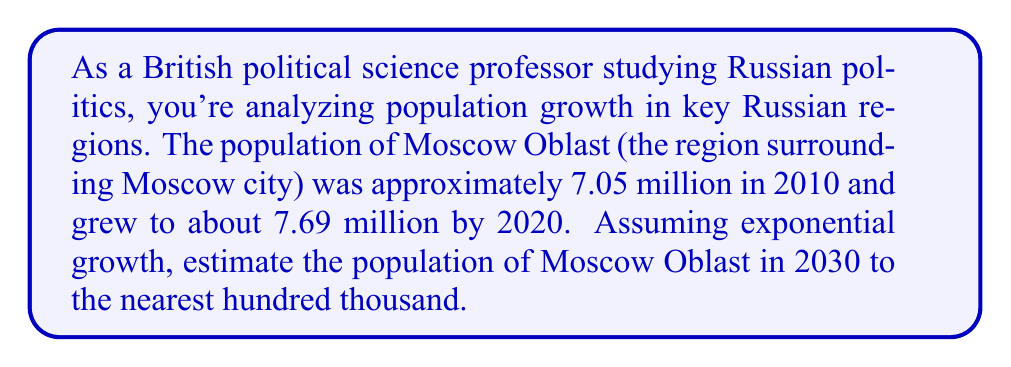Provide a solution to this math problem. To solve this problem, we'll use the exponential growth model:

$$P(t) = P_0 \cdot e^{rt}$$

Where:
$P(t)$ is the population at time $t$
$P_0$ is the initial population
$r$ is the growth rate
$t$ is the time elapsed

Step 1: Calculate the growth rate $r$
We have two data points:
$P_0 = 7.05$ million (2010)
$P(10) = 7.69$ million (2020)

Using the exponential growth formula:
$$7.69 = 7.05 \cdot e^{10r}$$

Solving for $r$:
$$\frac{7.69}{7.05} = e^{10r}$$
$$\ln(\frac{7.69}{7.05}) = 10r$$
$$r = \frac{\ln(\frac{7.69}{7.05})}{10} \approx 0.0087$$

Step 2: Use the growth rate to project the population in 2030
We now use the exponential growth formula with $t = 20$ (20 years from 2010 to 2030):

$$P(20) = 7.05 \cdot e^{0.0087 \cdot 20}$$
$$P(20) = 7.05 \cdot e^{0.174}$$
$$P(20) = 7.05 \cdot 1.1901$$
$$P(20) = 8.39$$ million

Step 3: Round to the nearest hundred thousand
8.39 million rounded to the nearest hundred thousand is 8.4 million.
Answer: 8.4 million 